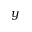Convert formula to latex. <formula><loc_0><loc_0><loc_500><loc_500>y</formula> 